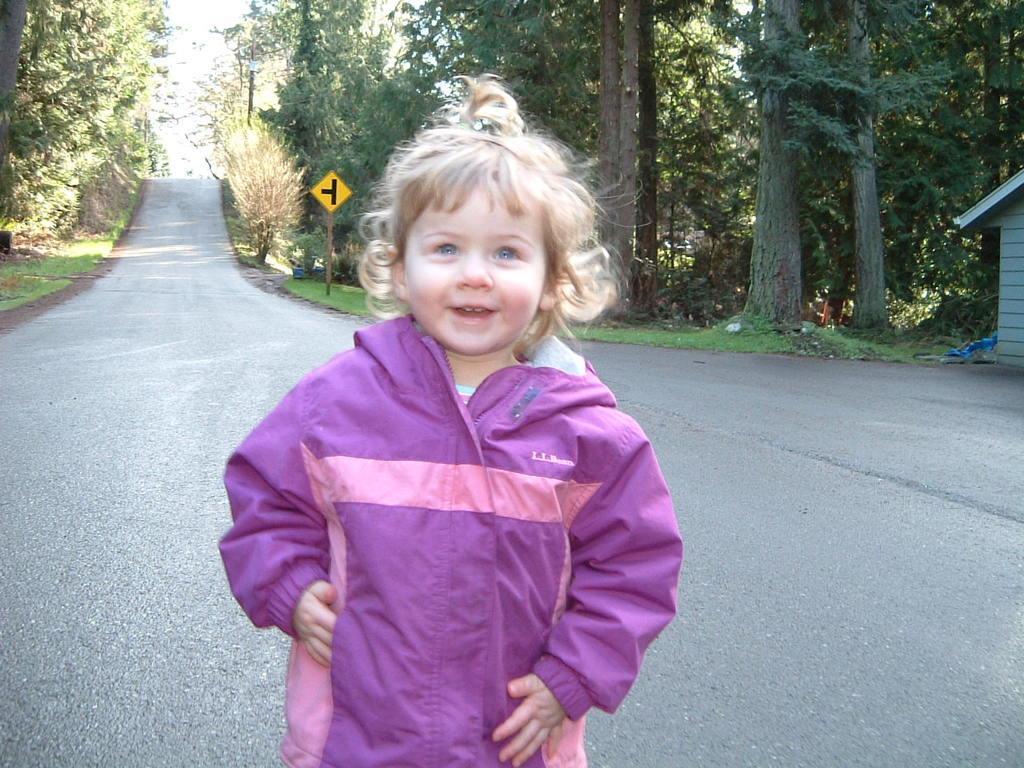Can you describe this image briefly? In this picture there is a girl who is wearing pink hoodie. She is smiling and standing on the road. On the right there is a wooden hut, beside that I can see some plastic covers. In the background I can see many trees and a sign board. In the top left there is a sky. 